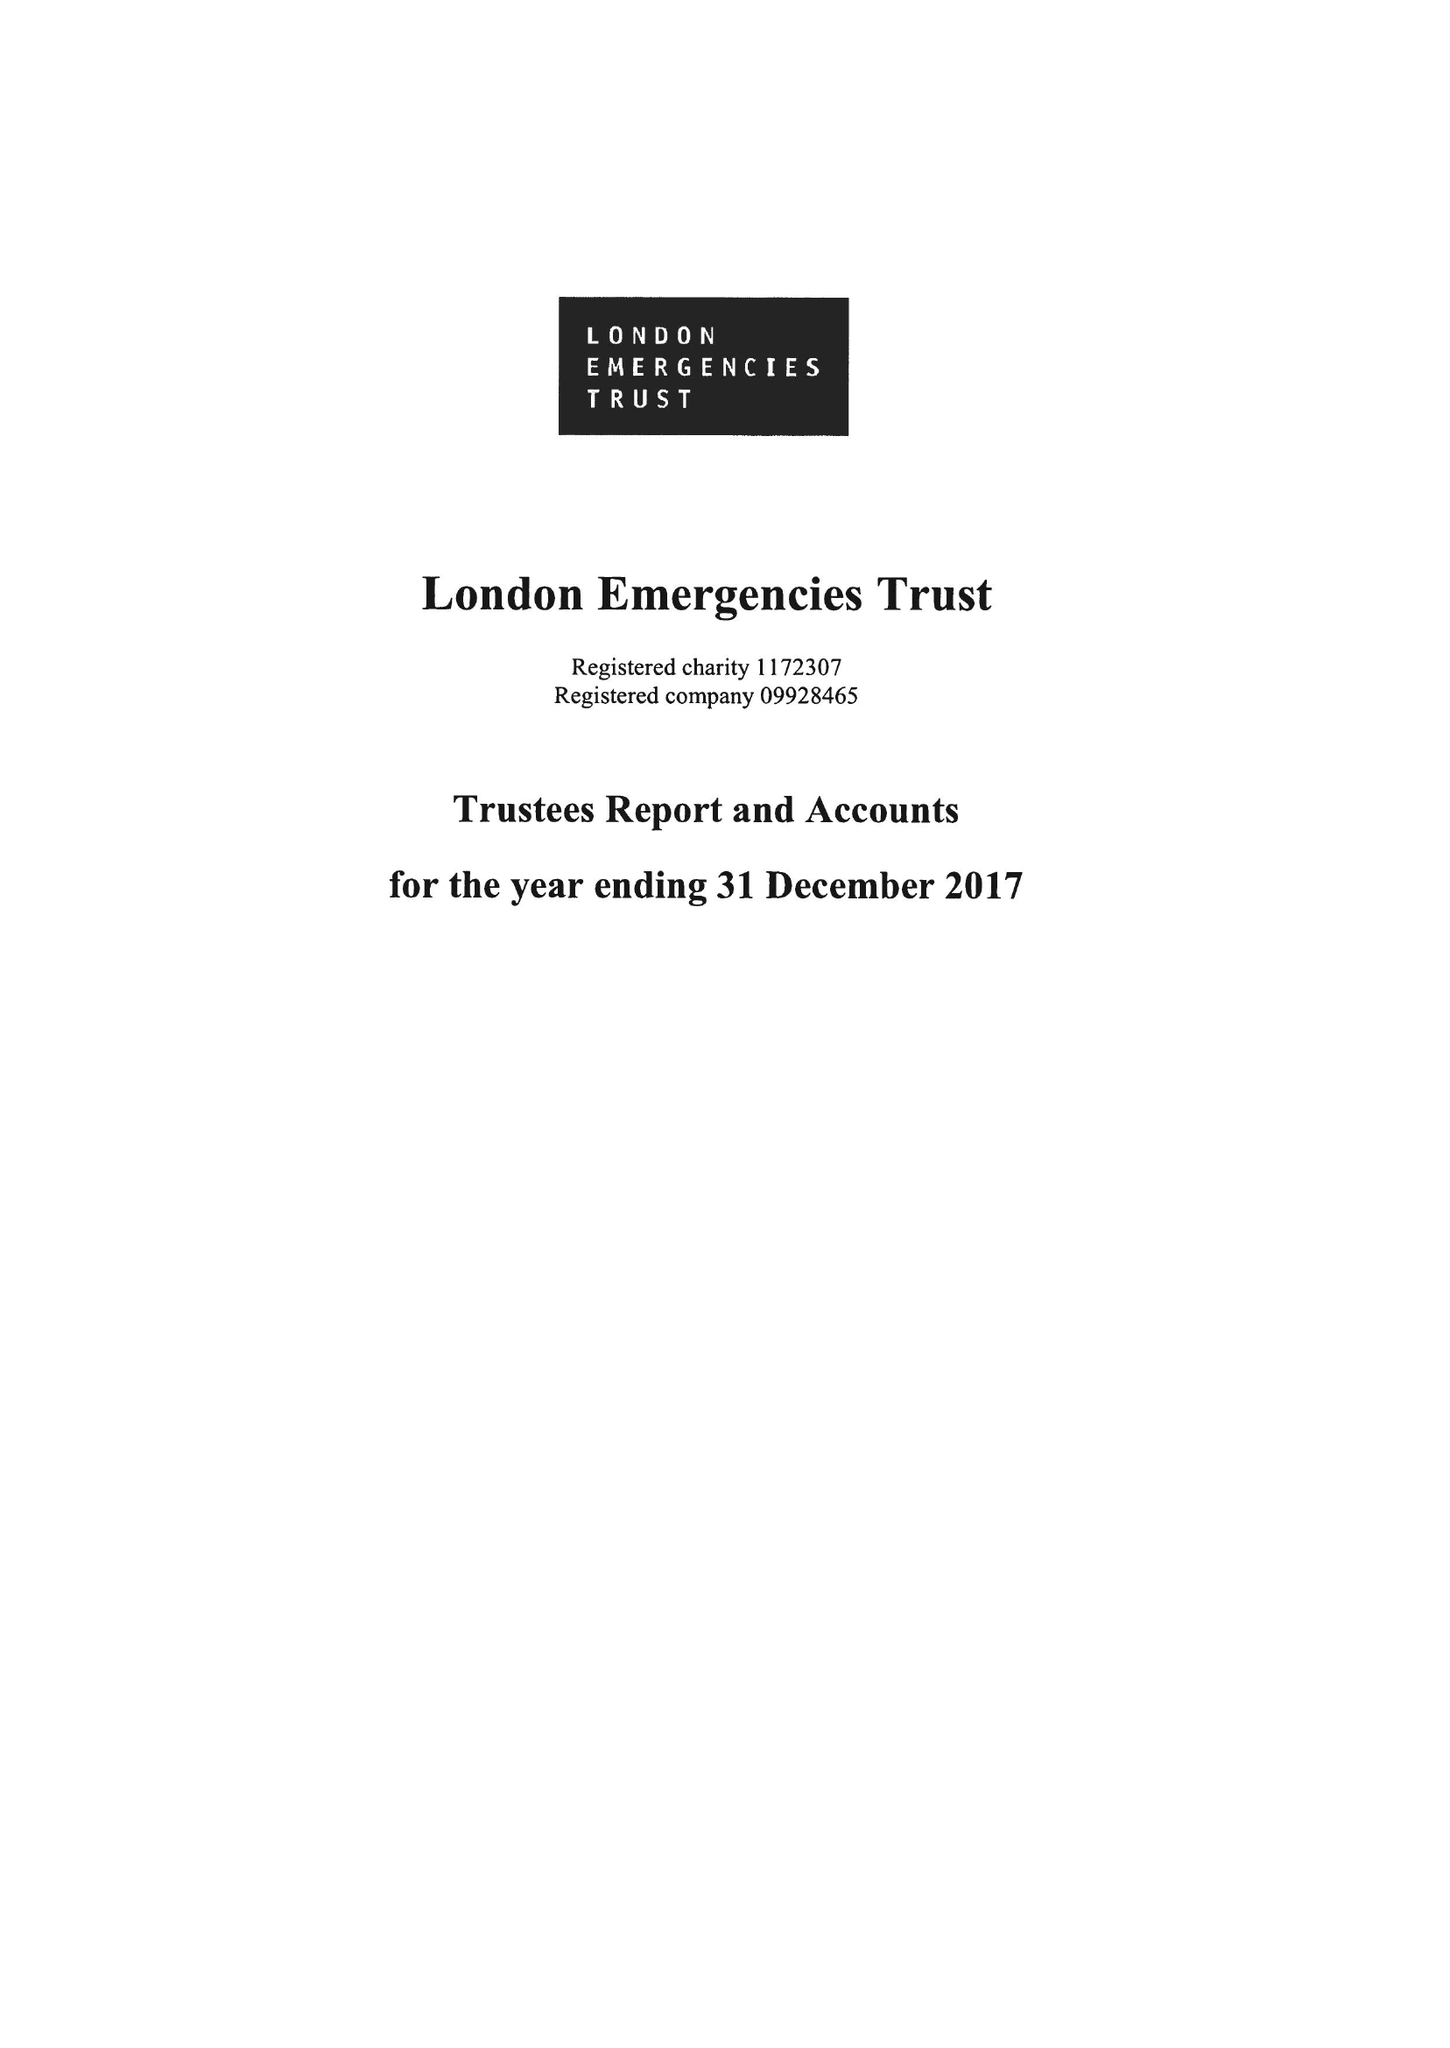What is the value for the report_date?
Answer the question using a single word or phrase. 2017-12-31 